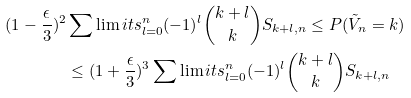<formula> <loc_0><loc_0><loc_500><loc_500>( 1 - \frac { \epsilon } { 3 } ) ^ { 2 } & \sum \lim i t s ^ { n } _ { \substack { l = 0 } } ( - 1 ) ^ { l } \binom { k + l } { k } S _ { k + l , n } \leq P ( \tilde { V } _ { n } = k ) \\ & \leq ( 1 + \frac { \epsilon } { 3 } ) ^ { 3 } \sum \lim i t s ^ { n } _ { \substack { l = 0 } } ( - 1 ) ^ { l } \binom { k + l } { k } S _ { k + l , n }</formula> 